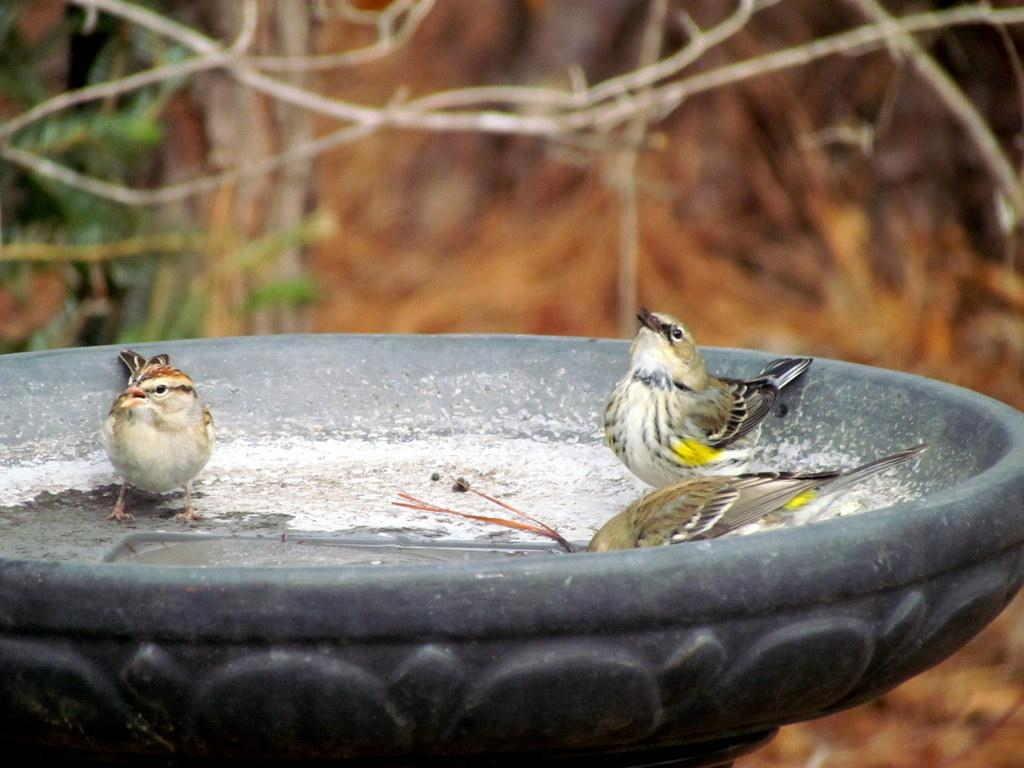What type of animals can be seen in the image? There are birds in the image. Where are the birds located in the image? The birds are present over a place. What can be seen in the background of the image? There are plants in the background of the image. How clear are the plants in the image? The plants are blurry in the image. What grade is the grape being taught in the image? There is no grape present in the image, and therefore no teaching or grade can be observed. What is the limit of the birds in the image? There is no limit mentioned or implied for the birds in the image; they are simply present over a place. 